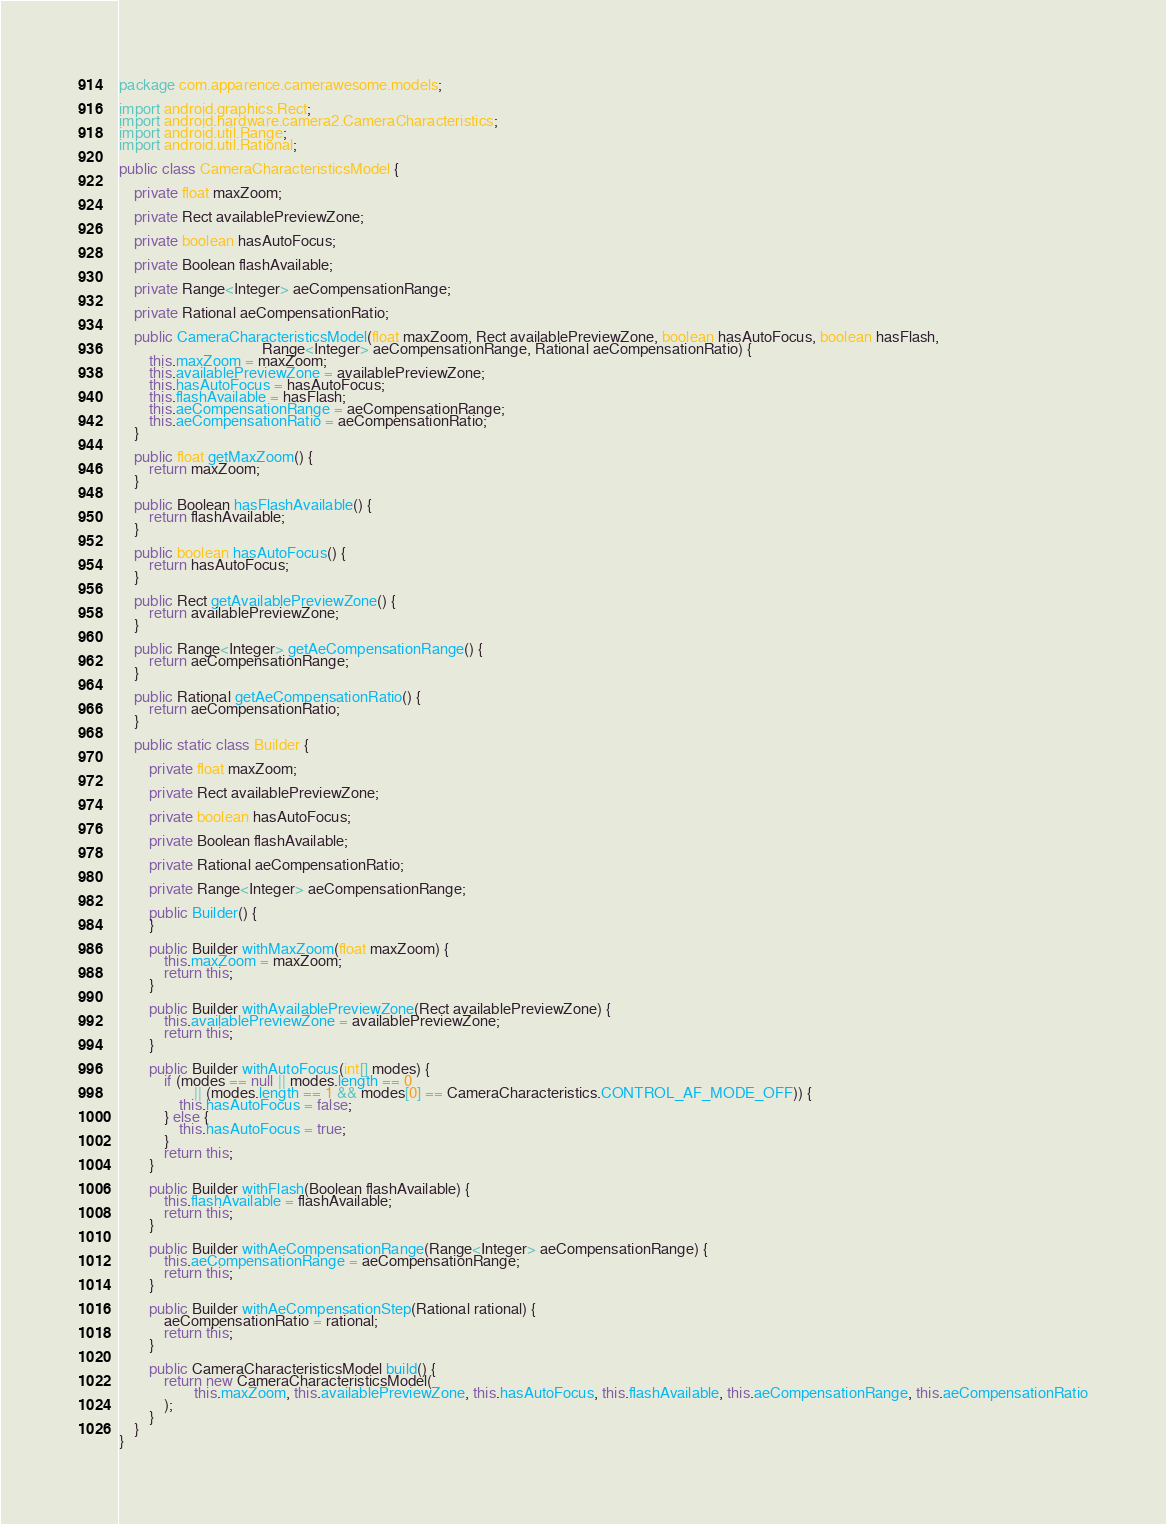<code> <loc_0><loc_0><loc_500><loc_500><_Java_>package com.apparence.camerawesome.models;

import android.graphics.Rect;
import android.hardware.camera2.CameraCharacteristics;
import android.util.Range;
import android.util.Rational;

public class CameraCharacteristicsModel {

    private float maxZoom;

    private Rect availablePreviewZone;

    private boolean hasAutoFocus;

    private Boolean flashAvailable;

    private Range<Integer> aeCompensationRange;

    private Rational aeCompensationRatio;

    public CameraCharacteristicsModel(float maxZoom, Rect availablePreviewZone, boolean hasAutoFocus, boolean hasFlash,
                                      Range<Integer> aeCompensationRange, Rational aeCompensationRatio) {
        this.maxZoom = maxZoom;
        this.availablePreviewZone = availablePreviewZone;
        this.hasAutoFocus = hasAutoFocus;
        this.flashAvailable = hasFlash;
        this.aeCompensationRange = aeCompensationRange;
        this.aeCompensationRatio = aeCompensationRatio;
    }

    public float getMaxZoom() {
        return maxZoom;
    }

    public Boolean hasFlashAvailable() {
        return flashAvailable;
    }

    public boolean hasAutoFocus() {
        return hasAutoFocus;
    }

    public Rect getAvailablePreviewZone() {
        return availablePreviewZone;
    }

    public Range<Integer> getAeCompensationRange() {
        return aeCompensationRange;
    }

    public Rational getAeCompensationRatio() {
        return aeCompensationRatio;
    }

    public static class Builder {

        private float maxZoom;

        private Rect availablePreviewZone;

        private boolean hasAutoFocus;

        private Boolean flashAvailable;

        private Rational aeCompensationRatio;

        private Range<Integer> aeCompensationRange;

        public Builder() {
        }

        public Builder withMaxZoom(float maxZoom) {
            this.maxZoom = maxZoom;
            return this;
        }

        public Builder withAvailablePreviewZone(Rect availablePreviewZone) {
            this.availablePreviewZone = availablePreviewZone;
            return this;
        }

        public Builder withAutoFocus(int[] modes) {
            if (modes == null || modes.length == 0
                    || (modes.length == 1 && modes[0] == CameraCharacteristics.CONTROL_AF_MODE_OFF)) {
                this.hasAutoFocus = false;
            } else {
                this.hasAutoFocus = true;
            }
            return this;
        }

        public Builder withFlash(Boolean flashAvailable) {
            this.flashAvailable = flashAvailable;
            return this;
        }

        public Builder withAeCompensationRange(Range<Integer> aeCompensationRange) {
            this.aeCompensationRange = aeCompensationRange;
            return this;
        }

        public Builder withAeCompensationStep(Rational rational) {
            aeCompensationRatio = rational;
            return this;
        }

        public CameraCharacteristicsModel build() {
            return new CameraCharacteristicsModel(
                    this.maxZoom, this.availablePreviewZone, this.hasAutoFocus, this.flashAvailable, this.aeCompensationRange, this.aeCompensationRatio
            );
        }
    }
}
</code> 